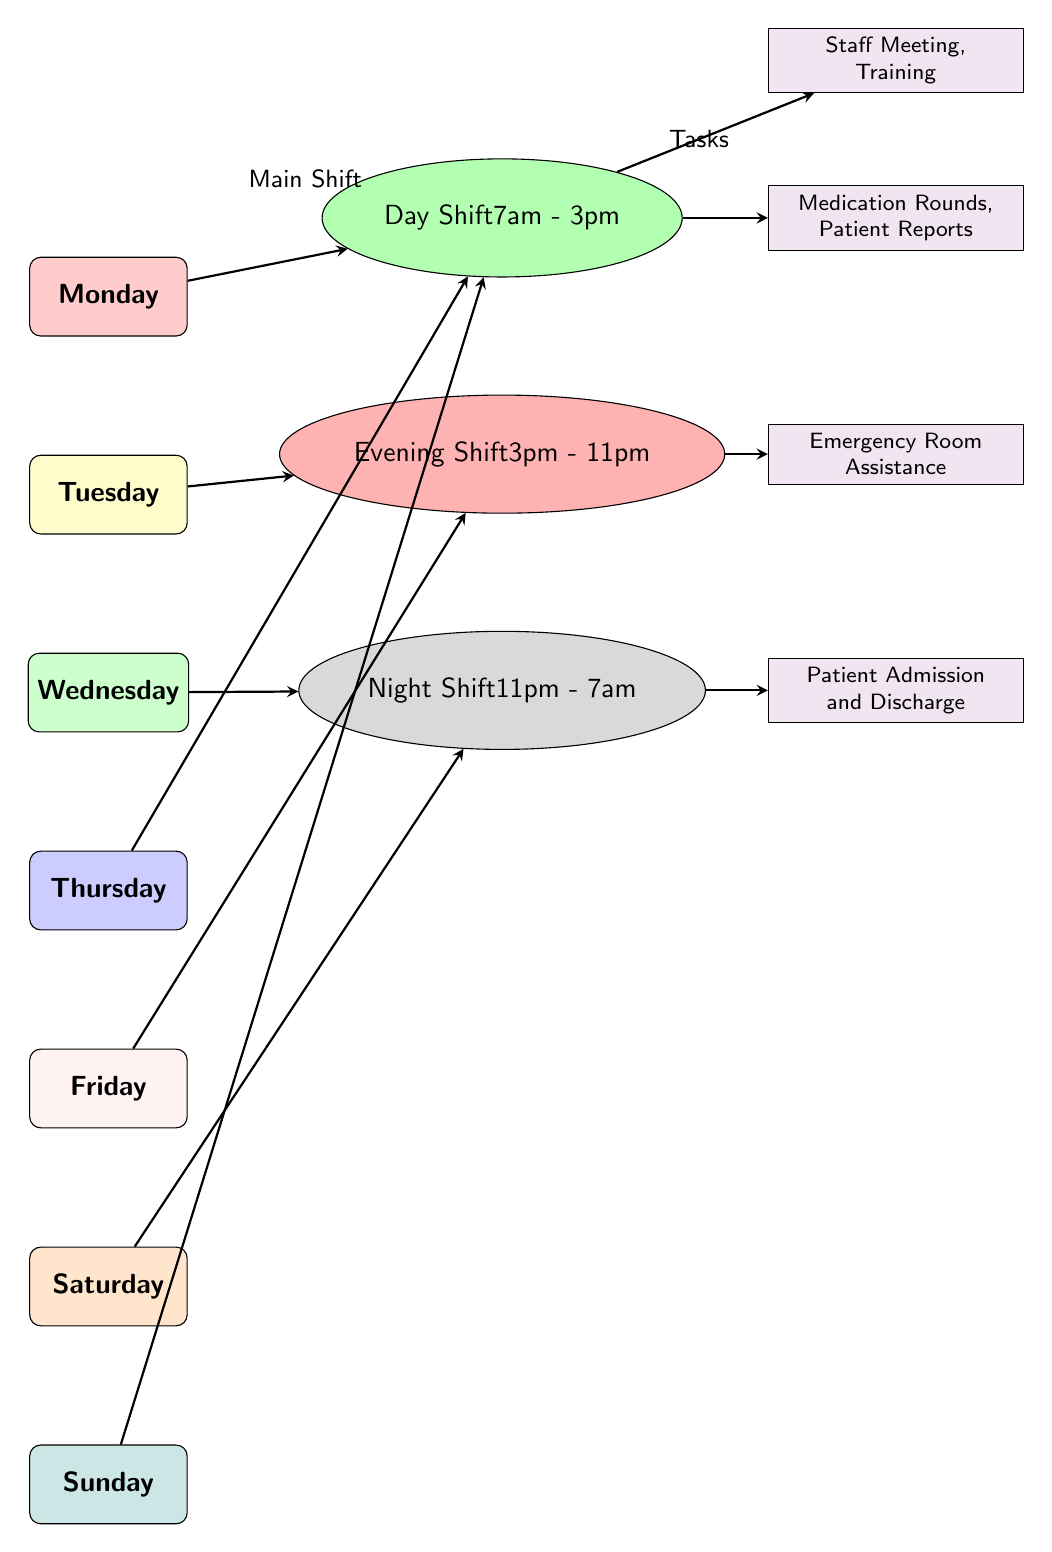What color represents Monday in the diagram? The color representing Monday in the diagram is red!20, as indicated by the fill color of the Monday node.
Answer: red!20 Which shift occurs on Wednesday? The shift occurring on Wednesday is the Night Shift, which is depicted as an ellipse labeled for night shifting hours.
Answer: Night Shift What is the time for the Evening Shift? The Evening Shift time is displayed within the ellipse for Evening Shift, which states the hours are from 3pm to 11pm.
Answer: 3pm - 11pm How many different shift types are represented in the diagram? There are three different shift types represented: Day Shift, Evening Shift, and Night Shift. This is determined by counting the labeled shift nodes.
Answer: 3 Which task is associated with the Day Shift? The task associated with the Day Shift is noted in the violet square connected to it, specifically mentioning Medication Rounds and Patient Reports.
Answer: Medication Rounds, Patient Reports What shift occurs during the weekend? The shifts during the weekend include Night Shift on Saturday and Day Shift on Sunday, as indicated by the connections to the respective day nodes.
Answer: Night Shift (Saturday), Day Shift (Sunday) Which day has a staff meeting? A staff meeting is associated with the Day Shift and is connected to the Thursday node through the Day shift node, indicating an event that occurs on that day.
Answer: Thursday How is the note for the Evening Shift summarized? The note associated with the Evening Shift emphasizes Emergency Room Assistance, and this is determined from the arrows leading from the Evening Shift node to its connected notes.
Answer: Emergency Room Assistance What is the format used for labeling the shifts? The labeling format for shifts includes the name of the shift followed by the hours, with text organized in an ellipse shape to visually distinguish them.
Answer: Shift name followed by hours 